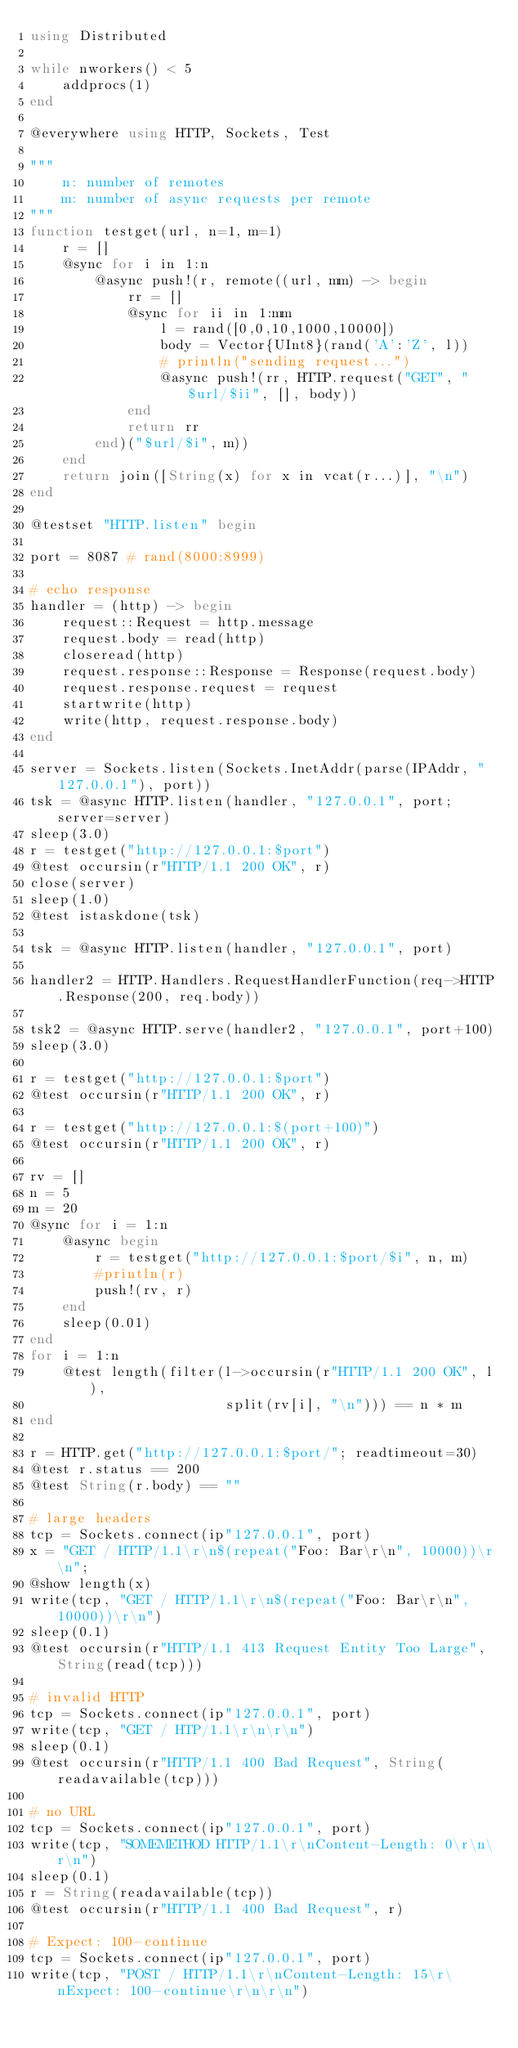Convert code to text. <code><loc_0><loc_0><loc_500><loc_500><_Julia_>using Distributed

while nworkers() < 5
    addprocs(1)
end

@everywhere using HTTP, Sockets, Test

"""
    n: number of remotes
    m: number of async requests per remote
"""
function testget(url, n=1, m=1)
    r = []
    @sync for i in 1:n
        @async push!(r, remote((url, mm) -> begin
            rr = []
            @sync for ii in 1:mm
                l = rand([0,0,10,1000,10000])
                body = Vector{UInt8}(rand('A':'Z', l))
                # println("sending request...")
                @async push!(rr, HTTP.request("GET", "$url/$ii", [], body))
            end
            return rr
        end)("$url/$i", m))
    end
    return join([String(x) for x in vcat(r...)], "\n")
end

@testset "HTTP.listen" begin

port = 8087 # rand(8000:8999)

# echo response
handler = (http) -> begin
    request::Request = http.message
    request.body = read(http)
    closeread(http)
    request.response::Response = Response(request.body)
    request.response.request = request
    startwrite(http)
    write(http, request.response.body)
end

server = Sockets.listen(Sockets.InetAddr(parse(IPAddr, "127.0.0.1"), port))
tsk = @async HTTP.listen(handler, "127.0.0.1", port; server=server)
sleep(3.0)
r = testget("http://127.0.0.1:$port")
@test occursin(r"HTTP/1.1 200 OK", r)
close(server)
sleep(1.0)
@test istaskdone(tsk)

tsk = @async HTTP.listen(handler, "127.0.0.1", port)

handler2 = HTTP.Handlers.RequestHandlerFunction(req->HTTP.Response(200, req.body))

tsk2 = @async HTTP.serve(handler2, "127.0.0.1", port+100)
sleep(3.0)

r = testget("http://127.0.0.1:$port")
@test occursin(r"HTTP/1.1 200 OK", r)

r = testget("http://127.0.0.1:$(port+100)")
@test occursin(r"HTTP/1.1 200 OK", r)

rv = []
n = 5
m = 20
@sync for i = 1:n
    @async begin
        r = testget("http://127.0.0.1:$port/$i", n, m)
        #println(r)
        push!(rv, r)
    end
    sleep(0.01)
end
for i = 1:n
    @test length(filter(l->occursin(r"HTTP/1.1 200 OK", l),
                        split(rv[i], "\n"))) == n * m
end

r = HTTP.get("http://127.0.0.1:$port/"; readtimeout=30)
@test r.status == 200
@test String(r.body) == ""

# large headers
tcp = Sockets.connect(ip"127.0.0.1", port)
x = "GET / HTTP/1.1\r\n$(repeat("Foo: Bar\r\n", 10000))\r\n";
@show length(x)
write(tcp, "GET / HTTP/1.1\r\n$(repeat("Foo: Bar\r\n", 10000))\r\n")
sleep(0.1)
@test occursin(r"HTTP/1.1 413 Request Entity Too Large", String(read(tcp)))

# invalid HTTP
tcp = Sockets.connect(ip"127.0.0.1", port)
write(tcp, "GET / HTP/1.1\r\n\r\n")
sleep(0.1)
@test occursin(r"HTTP/1.1 400 Bad Request", String(readavailable(tcp)))

# no URL
tcp = Sockets.connect(ip"127.0.0.1", port)
write(tcp, "SOMEMETHOD HTTP/1.1\r\nContent-Length: 0\r\n\r\n")
sleep(0.1)
r = String(readavailable(tcp))
@test occursin(r"HTTP/1.1 400 Bad Request", r)

# Expect: 100-continue
tcp = Sockets.connect(ip"127.0.0.1", port)
write(tcp, "POST / HTTP/1.1\r\nContent-Length: 15\r\nExpect: 100-continue\r\n\r\n")</code> 